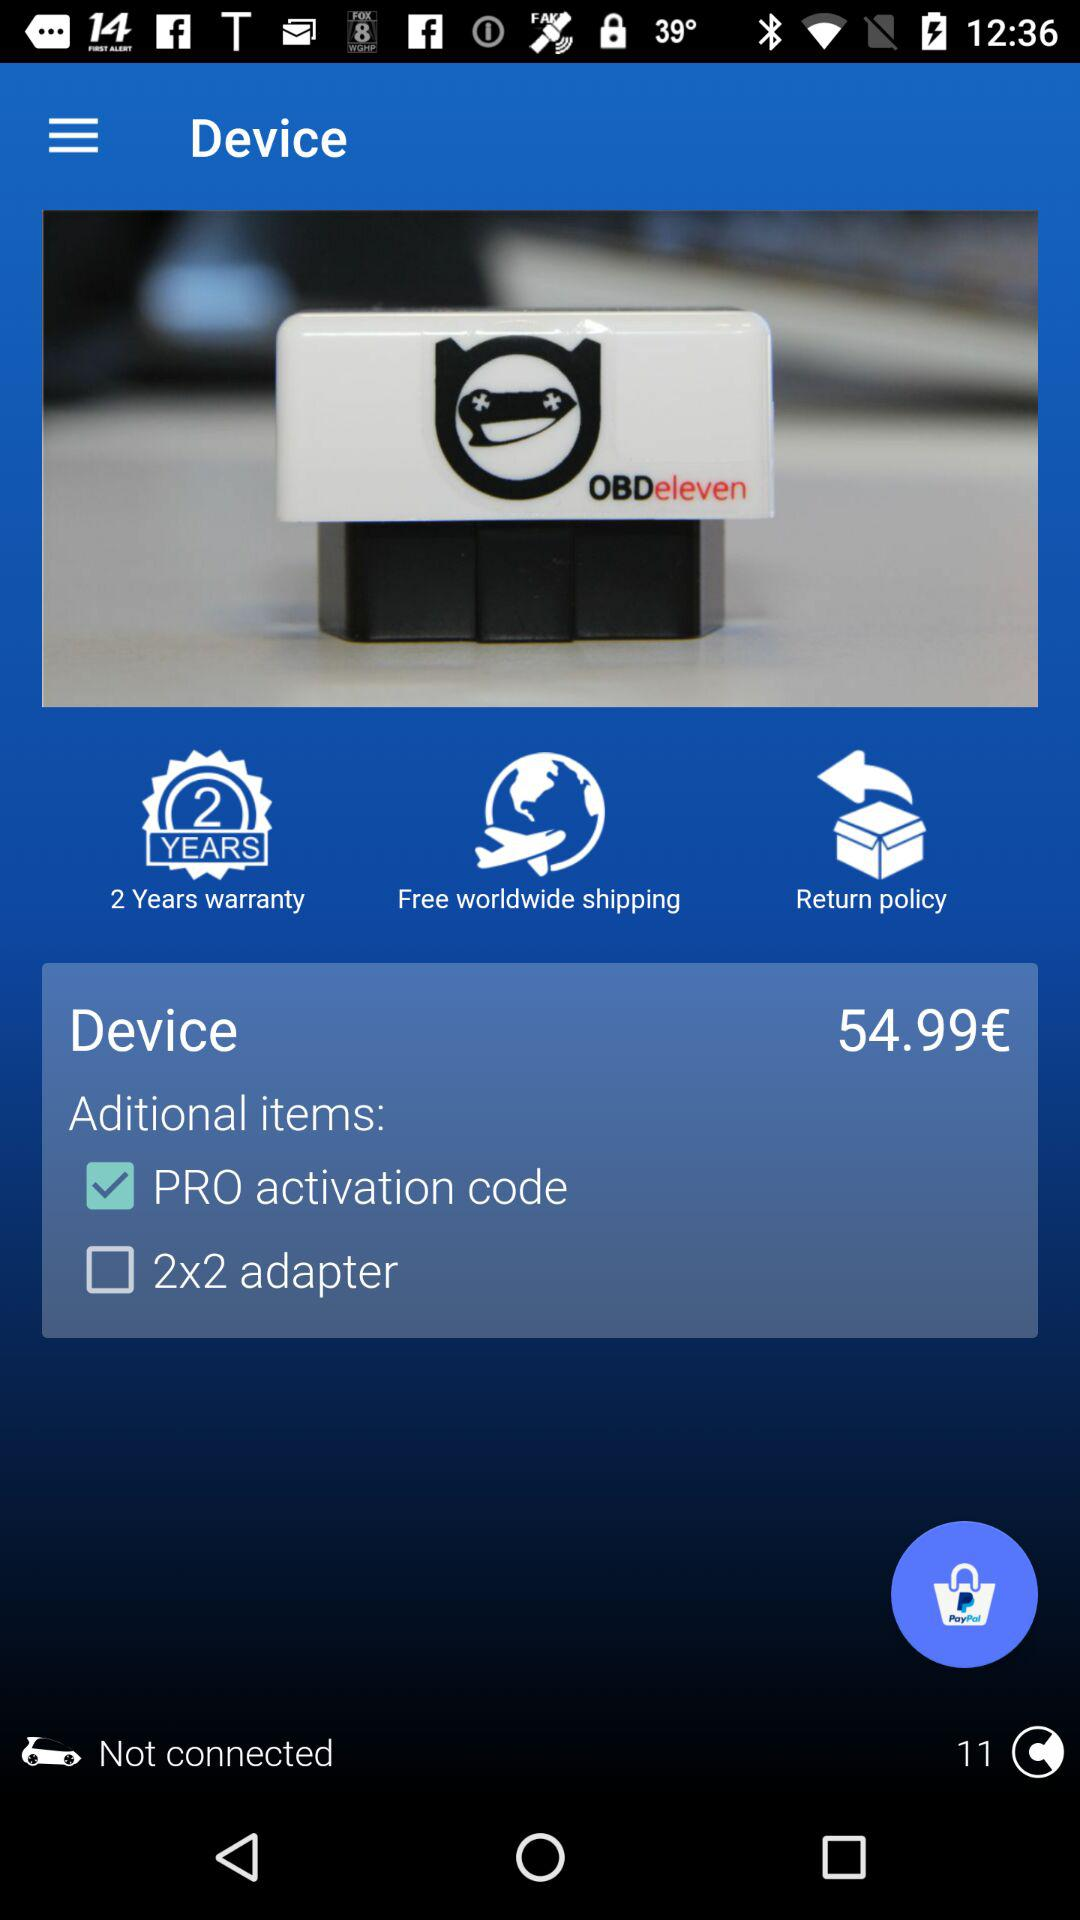What is the price of the device? The device is priced at 54.99 euros. 